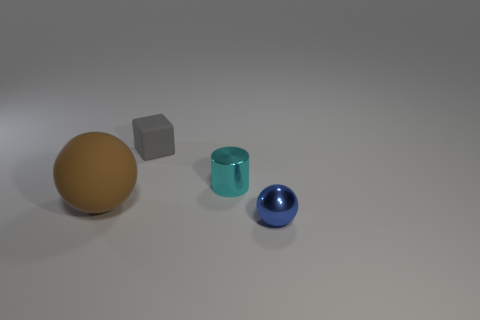Add 3 small gray rubber things. How many objects exist? 7 Subtract all blocks. How many objects are left? 3 Add 4 small cyan things. How many small cyan things are left? 5 Add 2 large shiny cylinders. How many large shiny cylinders exist? 2 Subtract 0 blue cylinders. How many objects are left? 4 Subtract all cyan shiny things. Subtract all cyan metallic objects. How many objects are left? 2 